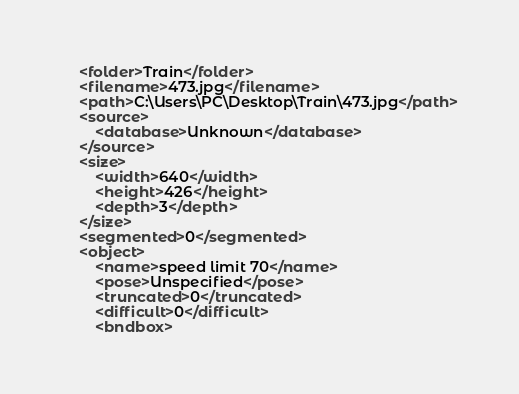Convert code to text. <code><loc_0><loc_0><loc_500><loc_500><_XML_>	<folder>Train</folder>
	<filename>473.jpg</filename>
	<path>C:\Users\PC\Desktop\Train\473.jpg</path>
	<source>
		<database>Unknown</database>
	</source>
	<size>
		<width>640</width>
		<height>426</height>
		<depth>3</depth>
	</size>
	<segmented>0</segmented>
	<object>
		<name>speed limit 70</name>
		<pose>Unspecified</pose>
		<truncated>0</truncated>
		<difficult>0</difficult>
		<bndbox></code> 